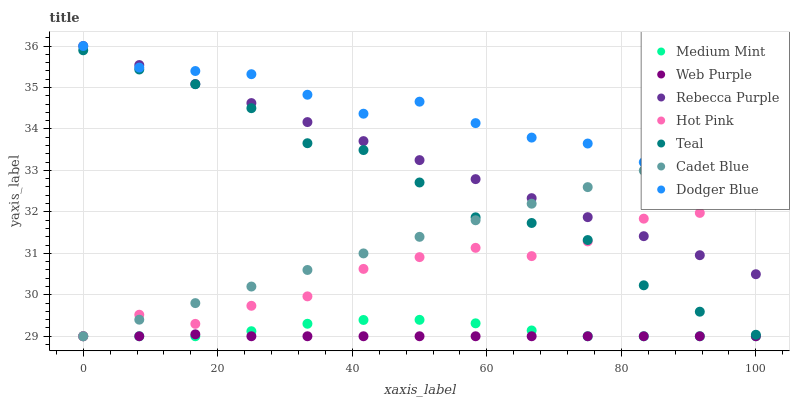Does Web Purple have the minimum area under the curve?
Answer yes or no. Yes. Does Dodger Blue have the maximum area under the curve?
Answer yes or no. Yes. Does Cadet Blue have the minimum area under the curve?
Answer yes or no. No. Does Cadet Blue have the maximum area under the curve?
Answer yes or no. No. Is Cadet Blue the smoothest?
Answer yes or no. Yes. Is Dodger Blue the roughest?
Answer yes or no. Yes. Is Hot Pink the smoothest?
Answer yes or no. No. Is Hot Pink the roughest?
Answer yes or no. No. Does Medium Mint have the lowest value?
Answer yes or no. Yes. Does Dodger Blue have the lowest value?
Answer yes or no. No. Does Rebecca Purple have the highest value?
Answer yes or no. Yes. Does Cadet Blue have the highest value?
Answer yes or no. No. Is Web Purple less than Teal?
Answer yes or no. Yes. Is Teal greater than Medium Mint?
Answer yes or no. Yes. Does Rebecca Purple intersect Cadet Blue?
Answer yes or no. Yes. Is Rebecca Purple less than Cadet Blue?
Answer yes or no. No. Is Rebecca Purple greater than Cadet Blue?
Answer yes or no. No. Does Web Purple intersect Teal?
Answer yes or no. No. 